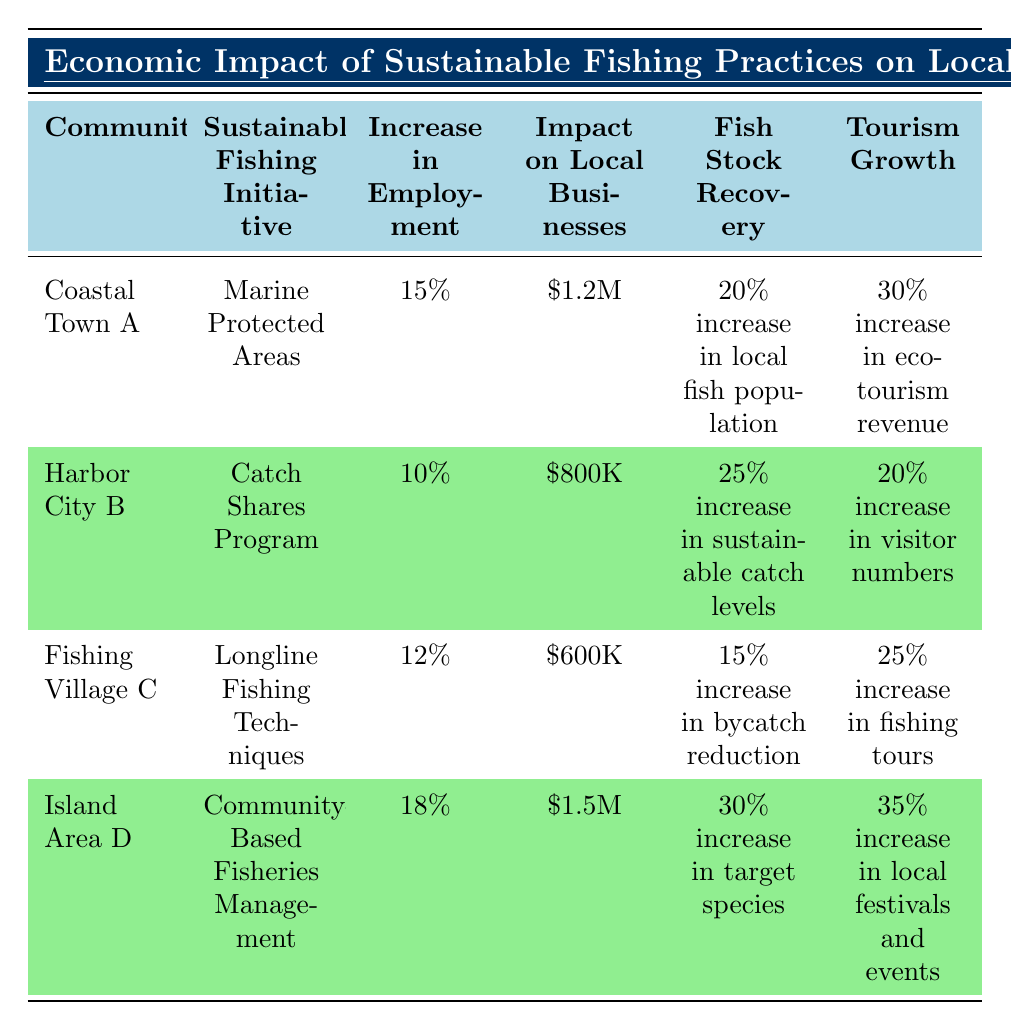What is the sustainable fishing initiative used by Coastal Town A? According to the table, Coastal Town A has implemented the "Marine Protected Areas" as its sustainable fishing initiative.
Answer: Marine Protected Areas Which community experienced the highest increase in tourism growth? The table indicates that Island Area D saw a 35% increase in local festivals and events, which is the highest among all communities listed.
Answer: Island Area D What was the impact on local businesses for Harbor City B? The table shows that the impact on local businesses for Harbor City B was $800K.
Answer: $800K Which community has the lowest percentage increase in employment? By comparing the increases in employment across the communities, it is clear that Harbor City B has the lowest increase at 10%.
Answer: Harbor City B What is the total impact on local businesses across all communities? Adding the impacts from each community: $1.2M + $800K + $600K + $1.5M = $4.1M total impact on local businesses.
Answer: $4.1M Is there a correlation between the initiatives and fish stock recovery? The table shows various sustainable fishing initiatives and their corresponding fish stock recovery percentages, which suggests that different initiatives lead to different recovery rates, such as Marine Protected Areas leading to a 20% increase, and Community-Based Fisheries Management leading to a 30% increase. Therefore, a correlation can be inferred.
Answer: Yes Which community has the highest increase in fish stock recovery and what percentage is it? From the data, Island Area D has the highest increase in fish stock recovery at 30%.
Answer: Island Area D, 30% What is the combined increase in employment from Fishing Village C and Coastal Town A? By adding their employment increases together: 15% (Coastal Town A) + 12% (Fishing Village C) = 27%.
Answer: 27% What percentage increase in sustainable fish stocks was observed in Harbor City B compared to Coastal Town A? Harbor City B had a 25% increase while Coastal Town A had a 20% increase, resulting in a difference of 5%.
Answer: 5% more in Harbor City B True or False: Fishing Village C had the highest impact on local businesses. The table shows that Island Area D had an impact of $1.5M, which is greater than Fishing Village C's $600K. Thus, the statement is false.
Answer: False 